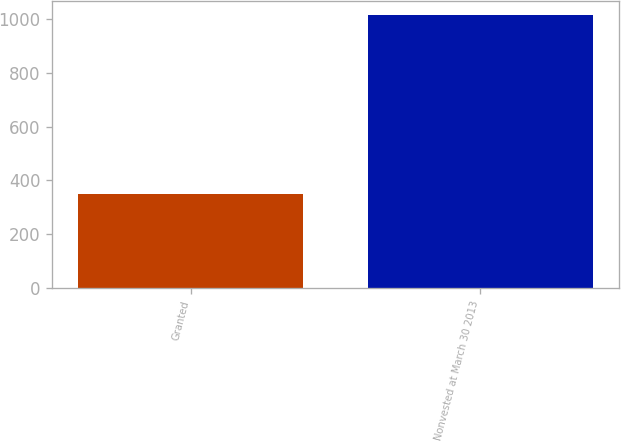Convert chart. <chart><loc_0><loc_0><loc_500><loc_500><bar_chart><fcel>Granted<fcel>Nonvested at March 30 2013<nl><fcel>351<fcel>1015<nl></chart> 